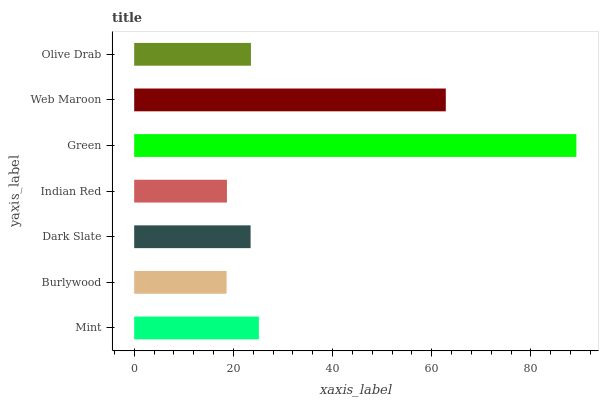Is Burlywood the minimum?
Answer yes or no. Yes. Is Green the maximum?
Answer yes or no. Yes. Is Dark Slate the minimum?
Answer yes or no. No. Is Dark Slate the maximum?
Answer yes or no. No. Is Dark Slate greater than Burlywood?
Answer yes or no. Yes. Is Burlywood less than Dark Slate?
Answer yes or no. Yes. Is Burlywood greater than Dark Slate?
Answer yes or no. No. Is Dark Slate less than Burlywood?
Answer yes or no. No. Is Olive Drab the high median?
Answer yes or no. Yes. Is Olive Drab the low median?
Answer yes or no. Yes. Is Green the high median?
Answer yes or no. No. Is Mint the low median?
Answer yes or no. No. 